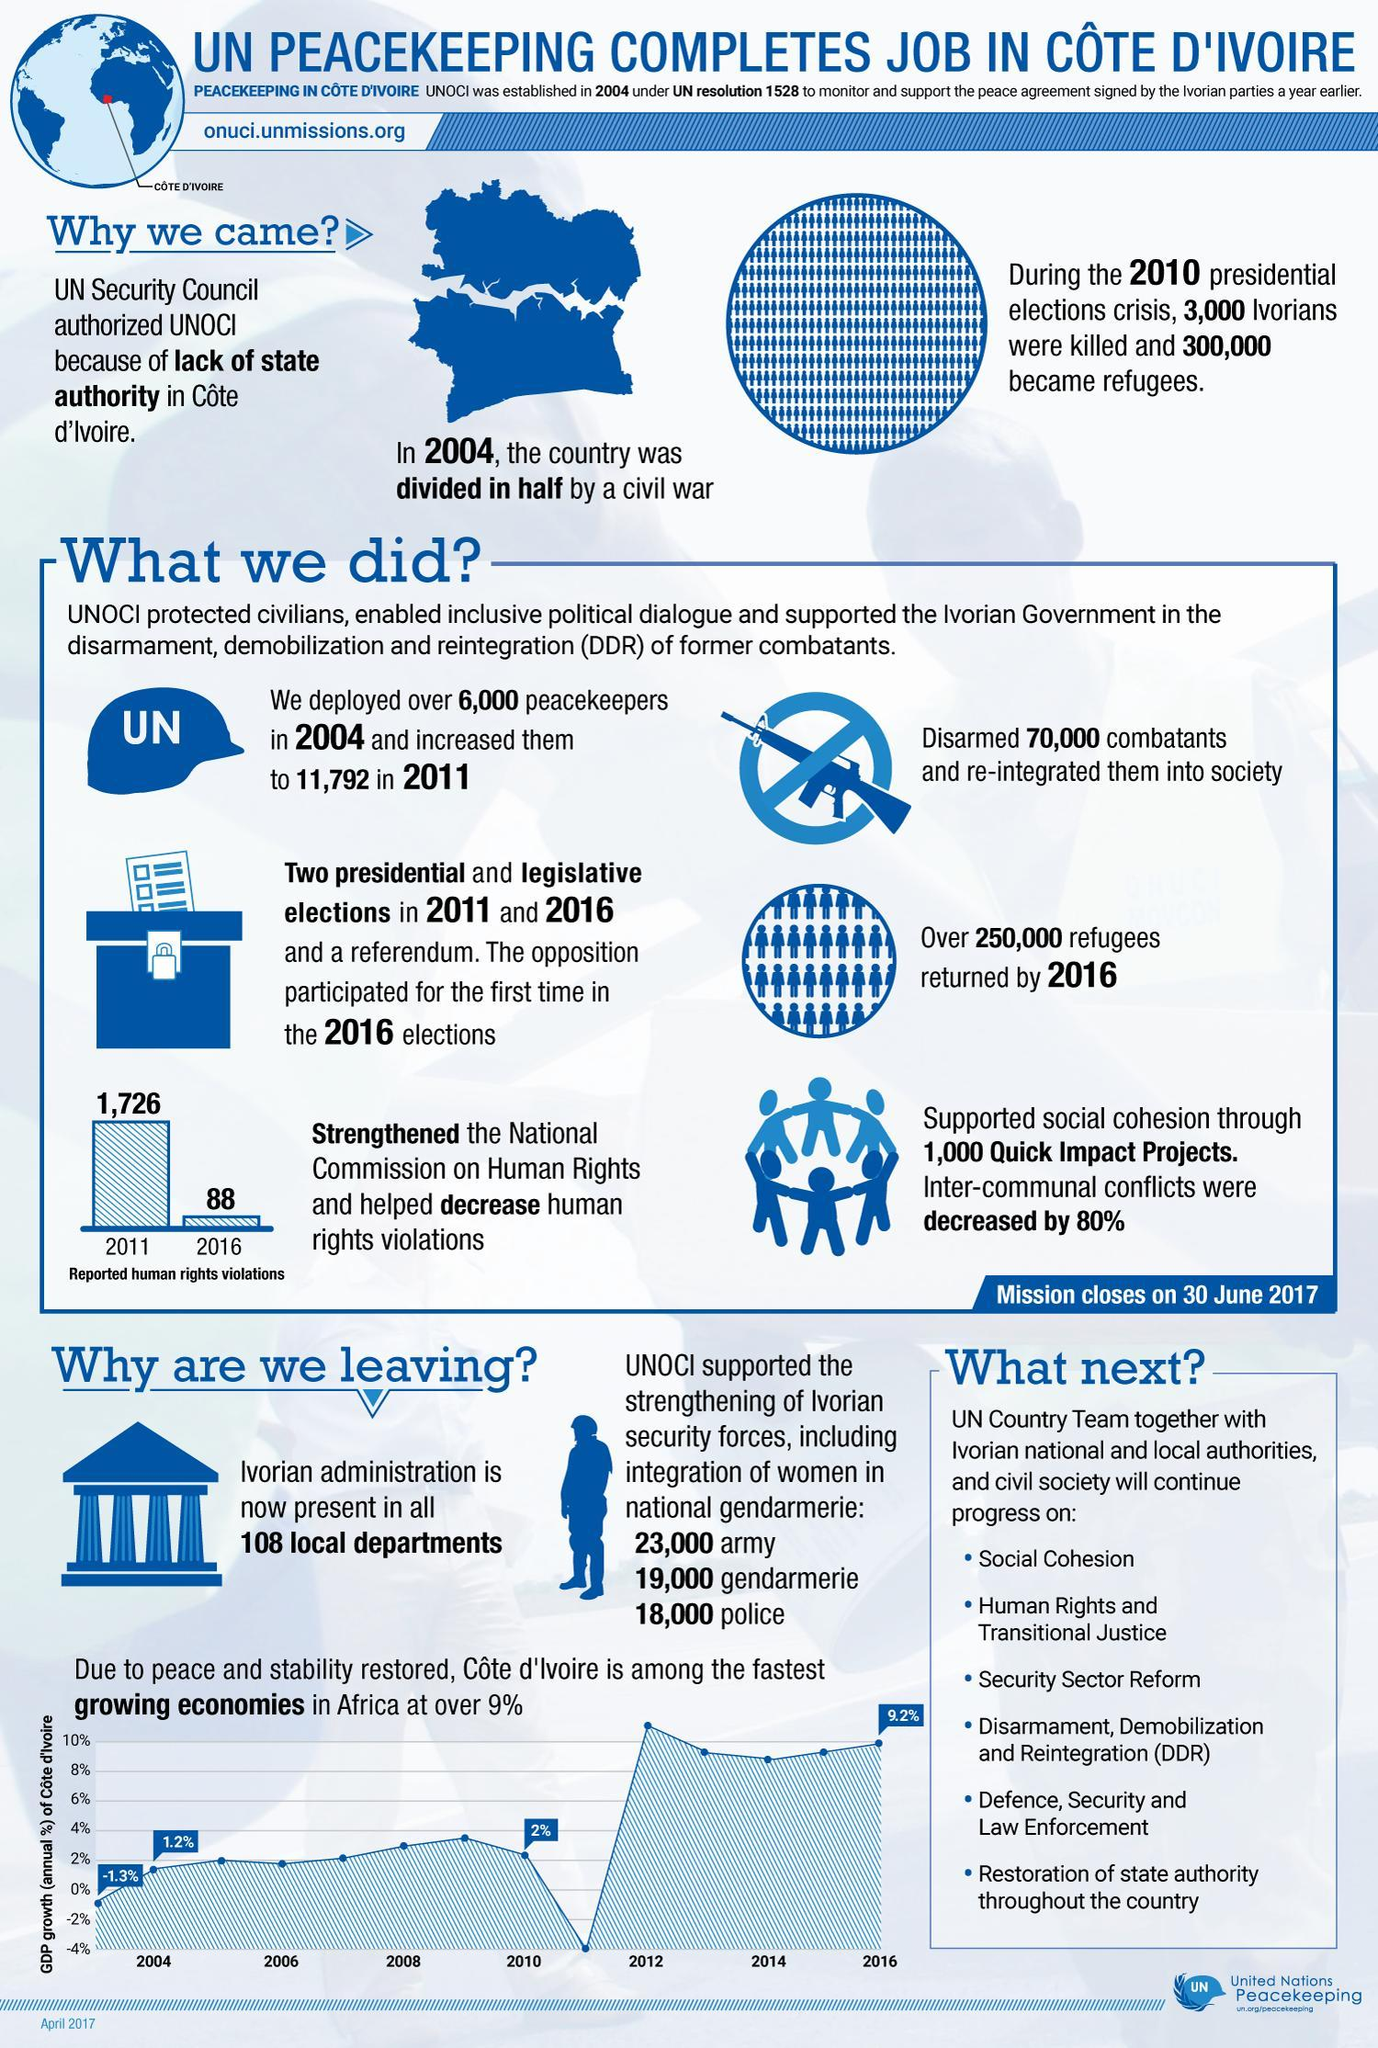What was the reason for mission in Cote d'Ivoire?
Answer the question with a short phrase. lack of state authority What was the annual GDP growth of Cote d' Ivoire in 2010? 2% By what number has reported human rights violation decreased from 2011 to 2016? 1,638 